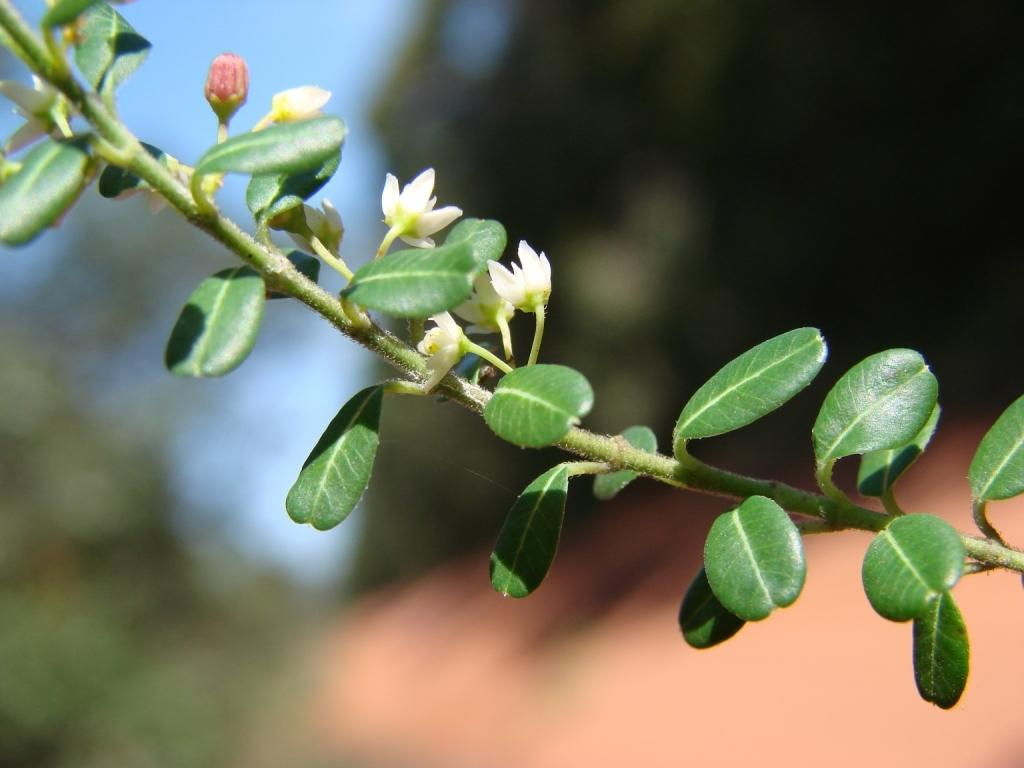What color are the flowers on the plant in the image? The flowers on the plant are white. What stage of growth are some of the flowers in? There are buds on the plant, indicating that some flowers are not yet fully bloomed. Can you describe the quality of the image? The image is blurry at the back. What type of straw is used to make the juice in the image? There is no straw or juice present in the image; it features a plant with white flowers and buds. 